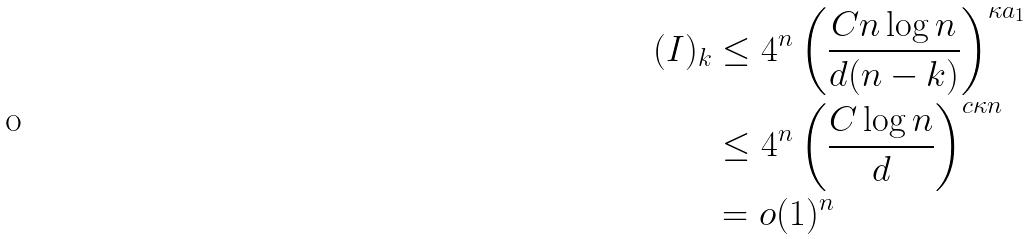Convert formula to latex. <formula><loc_0><loc_0><loc_500><loc_500>( I ) _ { k } & \leq 4 ^ { n } \left ( \frac { C n \log n } { d ( n - k ) } \right ) ^ { \kappa a _ { 1 } } \\ & \leq 4 ^ { n } \left ( \frac { C \log n } { d } \right ) ^ { c \kappa n } \\ & = o ( 1 ) ^ { n }</formula> 